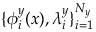Convert formula to latex. <formula><loc_0><loc_0><loc_500><loc_500>\{ \phi _ { i } ^ { y } ( x ) , \lambda _ { i } ^ { y } \} _ { i = 1 } ^ { N _ { y } }</formula> 